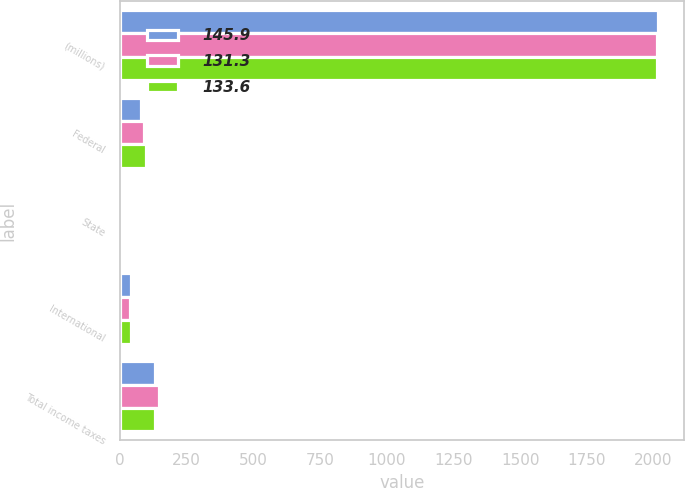Convert chart to OTSL. <chart><loc_0><loc_0><loc_500><loc_500><stacked_bar_chart><ecel><fcel>(millions)<fcel>Federal<fcel>State<fcel>International<fcel>Total income taxes<nl><fcel>145.9<fcel>2015<fcel>78.8<fcel>9.1<fcel>42.4<fcel>131.3<nl><fcel>131.3<fcel>2014<fcel>91.3<fcel>11.3<fcel>37.2<fcel>145.9<nl><fcel>133.6<fcel>2013<fcel>96.4<fcel>10.3<fcel>42.2<fcel>133.6<nl></chart> 